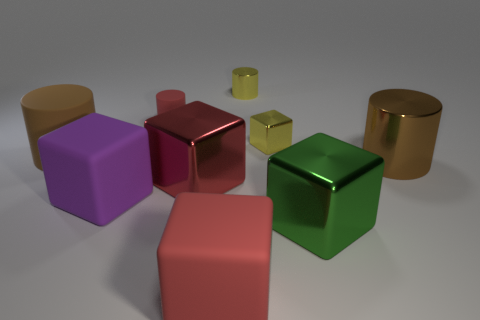Is the size of the red block in front of the green shiny block the same as the brown cylinder right of the large rubber cylinder?
Offer a very short reply. Yes. How many objects are either yellow rubber cylinders or large green metallic objects?
Provide a succinct answer. 1. Are there any tiny blue objects of the same shape as the green metallic thing?
Your response must be concise. No. Is the number of tiny metallic cylinders less than the number of rubber blocks?
Provide a short and direct response. Yes. Do the large red rubber object and the large green shiny object have the same shape?
Give a very brief answer. Yes. How many things are either tiny gray metallic balls or cylinders left of the small shiny cylinder?
Your answer should be very brief. 2. How many purple cylinders are there?
Your response must be concise. 0. Are there any yellow metallic cylinders that have the same size as the red matte cylinder?
Provide a succinct answer. Yes. Are there fewer red rubber cylinders that are in front of the small yellow metallic block than large green blocks?
Ensure brevity in your answer.  Yes. Is the yellow metallic cylinder the same size as the yellow block?
Ensure brevity in your answer.  Yes. 